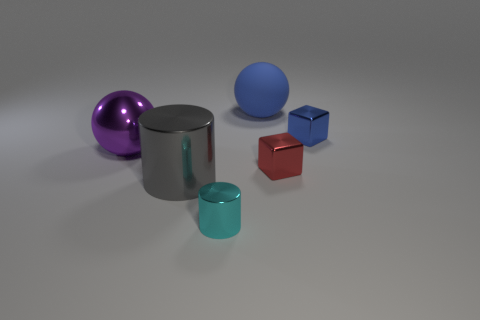Do the red metal cube and the shiny sphere have the same size?
Your answer should be very brief. No. How many tiny objects are blue objects or brown matte blocks?
Ensure brevity in your answer.  1. There is a tiny red cube; what number of big shiny spheres are to the left of it?
Provide a succinct answer. 1. Are there more big gray metal things that are in front of the big gray object than tiny red objects?
Provide a short and direct response. No. What shape is the small cyan thing that is the same material as the big cylinder?
Your answer should be compact. Cylinder. What is the color of the sphere to the right of the cylinder that is on the right side of the big gray shiny thing?
Offer a terse response. Blue. Do the big gray metallic thing and the large purple metal thing have the same shape?
Provide a succinct answer. No. There is a gray object that is the same shape as the cyan shiny thing; what material is it?
Your answer should be very brief. Metal. Are there any red metal things behind the ball in front of the large thing that is right of the cyan metal thing?
Give a very brief answer. No. Does the large rubber object have the same shape as the shiny object that is to the left of the large gray cylinder?
Your answer should be compact. Yes. 